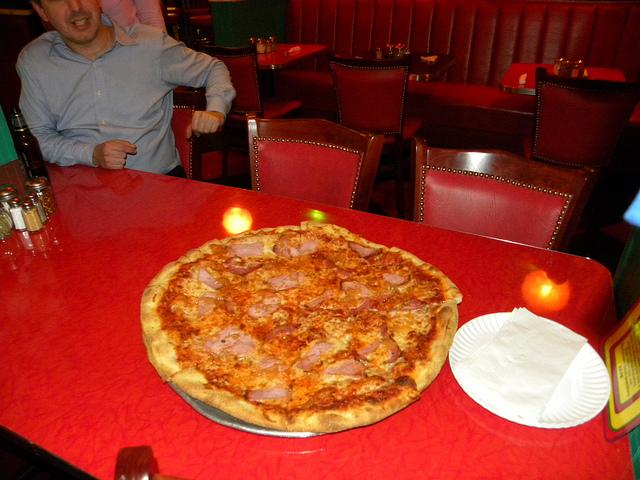What are the small candles on the table called? Please explain your reasoning. table lights. The candles are called tea lights. 